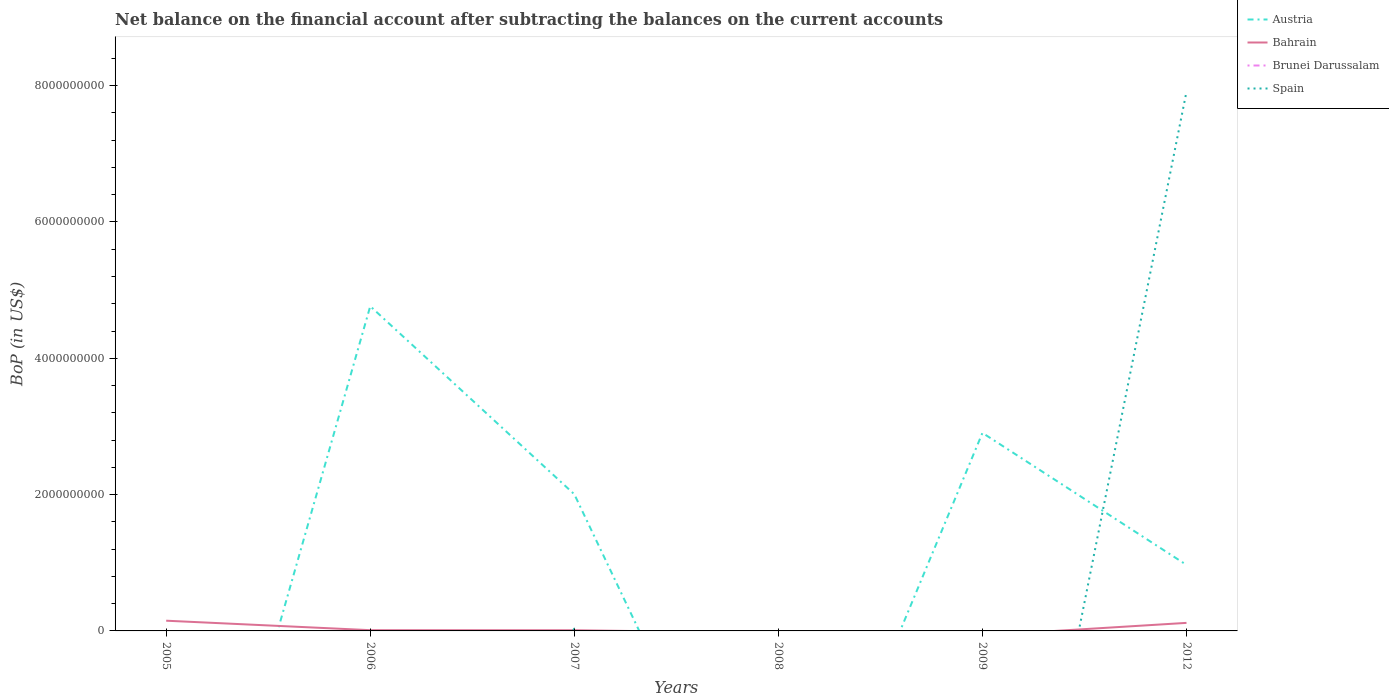How many different coloured lines are there?
Provide a short and direct response. 3. Does the line corresponding to Spain intersect with the line corresponding to Bahrain?
Give a very brief answer. Yes. What is the total Balance of Payments in Bahrain in the graph?
Provide a succinct answer. -1.08e+08. What is the difference between the highest and the second highest Balance of Payments in Austria?
Provide a succinct answer. 4.76e+09. Is the Balance of Payments in Austria strictly greater than the Balance of Payments in Spain over the years?
Ensure brevity in your answer.  No. How many lines are there?
Your answer should be very brief. 3. How many years are there in the graph?
Ensure brevity in your answer.  6. Are the values on the major ticks of Y-axis written in scientific E-notation?
Offer a very short reply. No. Does the graph contain any zero values?
Your response must be concise. Yes. Does the graph contain grids?
Offer a terse response. No. Where does the legend appear in the graph?
Offer a terse response. Top right. How many legend labels are there?
Make the answer very short. 4. How are the legend labels stacked?
Offer a very short reply. Vertical. What is the title of the graph?
Offer a very short reply. Net balance on the financial account after subtracting the balances on the current accounts. Does "Namibia" appear as one of the legend labels in the graph?
Offer a very short reply. No. What is the label or title of the X-axis?
Provide a succinct answer. Years. What is the label or title of the Y-axis?
Offer a terse response. BoP (in US$). What is the BoP (in US$) of Bahrain in 2005?
Provide a short and direct response. 1.50e+08. What is the BoP (in US$) in Spain in 2005?
Give a very brief answer. 0. What is the BoP (in US$) of Austria in 2006?
Offer a terse response. 4.76e+09. What is the BoP (in US$) in Bahrain in 2006?
Your response must be concise. 1.10e+07. What is the BoP (in US$) of Brunei Darussalam in 2006?
Provide a short and direct response. 0. What is the BoP (in US$) of Spain in 2006?
Ensure brevity in your answer.  0. What is the BoP (in US$) in Austria in 2007?
Ensure brevity in your answer.  2.00e+09. What is the BoP (in US$) of Bahrain in 2007?
Provide a short and direct response. 1.02e+07. What is the BoP (in US$) in Spain in 2007?
Your answer should be compact. 3.16e+07. What is the BoP (in US$) of Austria in 2008?
Your response must be concise. 0. What is the BoP (in US$) in Bahrain in 2008?
Offer a terse response. 0. What is the BoP (in US$) of Brunei Darussalam in 2008?
Ensure brevity in your answer.  0. What is the BoP (in US$) of Austria in 2009?
Offer a terse response. 2.91e+09. What is the BoP (in US$) in Bahrain in 2009?
Your answer should be compact. 0. What is the BoP (in US$) in Brunei Darussalam in 2009?
Offer a terse response. 0. What is the BoP (in US$) in Austria in 2012?
Ensure brevity in your answer.  9.69e+08. What is the BoP (in US$) of Bahrain in 2012?
Provide a short and direct response. 1.18e+08. What is the BoP (in US$) of Brunei Darussalam in 2012?
Offer a terse response. 0. What is the BoP (in US$) of Spain in 2012?
Ensure brevity in your answer.  7.91e+09. Across all years, what is the maximum BoP (in US$) of Austria?
Give a very brief answer. 4.76e+09. Across all years, what is the maximum BoP (in US$) in Bahrain?
Provide a succinct answer. 1.50e+08. Across all years, what is the maximum BoP (in US$) in Spain?
Provide a short and direct response. 7.91e+09. Across all years, what is the minimum BoP (in US$) of Bahrain?
Make the answer very short. 0. What is the total BoP (in US$) in Austria in the graph?
Keep it short and to the point. 1.06e+1. What is the total BoP (in US$) in Bahrain in the graph?
Make the answer very short. 2.89e+08. What is the total BoP (in US$) in Brunei Darussalam in the graph?
Ensure brevity in your answer.  0. What is the total BoP (in US$) of Spain in the graph?
Give a very brief answer. 7.94e+09. What is the difference between the BoP (in US$) in Bahrain in 2005 and that in 2006?
Provide a succinct answer. 1.39e+08. What is the difference between the BoP (in US$) in Bahrain in 2005 and that in 2007?
Make the answer very short. 1.40e+08. What is the difference between the BoP (in US$) in Bahrain in 2005 and that in 2012?
Your response must be concise. 3.19e+07. What is the difference between the BoP (in US$) of Austria in 2006 and that in 2007?
Offer a terse response. 2.76e+09. What is the difference between the BoP (in US$) of Bahrain in 2006 and that in 2007?
Offer a very short reply. 7.93e+05. What is the difference between the BoP (in US$) of Austria in 2006 and that in 2009?
Give a very brief answer. 1.86e+09. What is the difference between the BoP (in US$) of Austria in 2006 and that in 2012?
Your response must be concise. 3.80e+09. What is the difference between the BoP (in US$) of Bahrain in 2006 and that in 2012?
Keep it short and to the point. -1.07e+08. What is the difference between the BoP (in US$) in Austria in 2007 and that in 2009?
Provide a succinct answer. -9.00e+08. What is the difference between the BoP (in US$) of Austria in 2007 and that in 2012?
Provide a succinct answer. 1.04e+09. What is the difference between the BoP (in US$) of Bahrain in 2007 and that in 2012?
Your answer should be very brief. -1.08e+08. What is the difference between the BoP (in US$) in Spain in 2007 and that in 2012?
Give a very brief answer. -7.88e+09. What is the difference between the BoP (in US$) in Austria in 2009 and that in 2012?
Offer a very short reply. 1.94e+09. What is the difference between the BoP (in US$) in Bahrain in 2005 and the BoP (in US$) in Spain in 2007?
Give a very brief answer. 1.18e+08. What is the difference between the BoP (in US$) of Bahrain in 2005 and the BoP (in US$) of Spain in 2012?
Provide a short and direct response. -7.76e+09. What is the difference between the BoP (in US$) in Austria in 2006 and the BoP (in US$) in Bahrain in 2007?
Your answer should be compact. 4.75e+09. What is the difference between the BoP (in US$) in Austria in 2006 and the BoP (in US$) in Spain in 2007?
Provide a short and direct response. 4.73e+09. What is the difference between the BoP (in US$) of Bahrain in 2006 and the BoP (in US$) of Spain in 2007?
Provide a succinct answer. -2.07e+07. What is the difference between the BoP (in US$) in Austria in 2006 and the BoP (in US$) in Bahrain in 2012?
Your answer should be compact. 4.65e+09. What is the difference between the BoP (in US$) in Austria in 2006 and the BoP (in US$) in Spain in 2012?
Make the answer very short. -3.15e+09. What is the difference between the BoP (in US$) in Bahrain in 2006 and the BoP (in US$) in Spain in 2012?
Your answer should be compact. -7.90e+09. What is the difference between the BoP (in US$) of Austria in 2007 and the BoP (in US$) of Bahrain in 2012?
Provide a succinct answer. 1.89e+09. What is the difference between the BoP (in US$) of Austria in 2007 and the BoP (in US$) of Spain in 2012?
Provide a succinct answer. -5.91e+09. What is the difference between the BoP (in US$) in Bahrain in 2007 and the BoP (in US$) in Spain in 2012?
Give a very brief answer. -7.90e+09. What is the difference between the BoP (in US$) in Austria in 2009 and the BoP (in US$) in Bahrain in 2012?
Your answer should be very brief. 2.79e+09. What is the difference between the BoP (in US$) in Austria in 2009 and the BoP (in US$) in Spain in 2012?
Keep it short and to the point. -5.01e+09. What is the average BoP (in US$) in Austria per year?
Ensure brevity in your answer.  1.77e+09. What is the average BoP (in US$) of Bahrain per year?
Ensure brevity in your answer.  4.82e+07. What is the average BoP (in US$) of Brunei Darussalam per year?
Keep it short and to the point. 0. What is the average BoP (in US$) in Spain per year?
Your response must be concise. 1.32e+09. In the year 2006, what is the difference between the BoP (in US$) of Austria and BoP (in US$) of Bahrain?
Give a very brief answer. 4.75e+09. In the year 2007, what is the difference between the BoP (in US$) of Austria and BoP (in US$) of Bahrain?
Provide a succinct answer. 1.99e+09. In the year 2007, what is the difference between the BoP (in US$) in Austria and BoP (in US$) in Spain?
Your answer should be very brief. 1.97e+09. In the year 2007, what is the difference between the BoP (in US$) of Bahrain and BoP (in US$) of Spain?
Your answer should be very brief. -2.15e+07. In the year 2012, what is the difference between the BoP (in US$) of Austria and BoP (in US$) of Bahrain?
Offer a very short reply. 8.51e+08. In the year 2012, what is the difference between the BoP (in US$) of Austria and BoP (in US$) of Spain?
Provide a succinct answer. -6.94e+09. In the year 2012, what is the difference between the BoP (in US$) in Bahrain and BoP (in US$) in Spain?
Your answer should be compact. -7.79e+09. What is the ratio of the BoP (in US$) in Bahrain in 2005 to that in 2006?
Provide a short and direct response. 13.69. What is the ratio of the BoP (in US$) of Bahrain in 2005 to that in 2007?
Offer a terse response. 14.76. What is the ratio of the BoP (in US$) of Bahrain in 2005 to that in 2012?
Make the answer very short. 1.27. What is the ratio of the BoP (in US$) in Austria in 2006 to that in 2007?
Keep it short and to the point. 2.38. What is the ratio of the BoP (in US$) of Bahrain in 2006 to that in 2007?
Provide a succinct answer. 1.08. What is the ratio of the BoP (in US$) of Austria in 2006 to that in 2009?
Offer a terse response. 1.64. What is the ratio of the BoP (in US$) in Austria in 2006 to that in 2012?
Ensure brevity in your answer.  4.92. What is the ratio of the BoP (in US$) in Bahrain in 2006 to that in 2012?
Keep it short and to the point. 0.09. What is the ratio of the BoP (in US$) in Austria in 2007 to that in 2009?
Ensure brevity in your answer.  0.69. What is the ratio of the BoP (in US$) of Austria in 2007 to that in 2012?
Your answer should be very brief. 2.07. What is the ratio of the BoP (in US$) in Bahrain in 2007 to that in 2012?
Offer a very short reply. 0.09. What is the ratio of the BoP (in US$) of Spain in 2007 to that in 2012?
Offer a terse response. 0. What is the ratio of the BoP (in US$) of Austria in 2009 to that in 2012?
Offer a very short reply. 3. What is the difference between the highest and the second highest BoP (in US$) in Austria?
Your response must be concise. 1.86e+09. What is the difference between the highest and the second highest BoP (in US$) of Bahrain?
Give a very brief answer. 3.19e+07. What is the difference between the highest and the lowest BoP (in US$) of Austria?
Provide a succinct answer. 4.76e+09. What is the difference between the highest and the lowest BoP (in US$) in Bahrain?
Provide a succinct answer. 1.50e+08. What is the difference between the highest and the lowest BoP (in US$) of Spain?
Offer a terse response. 7.91e+09. 